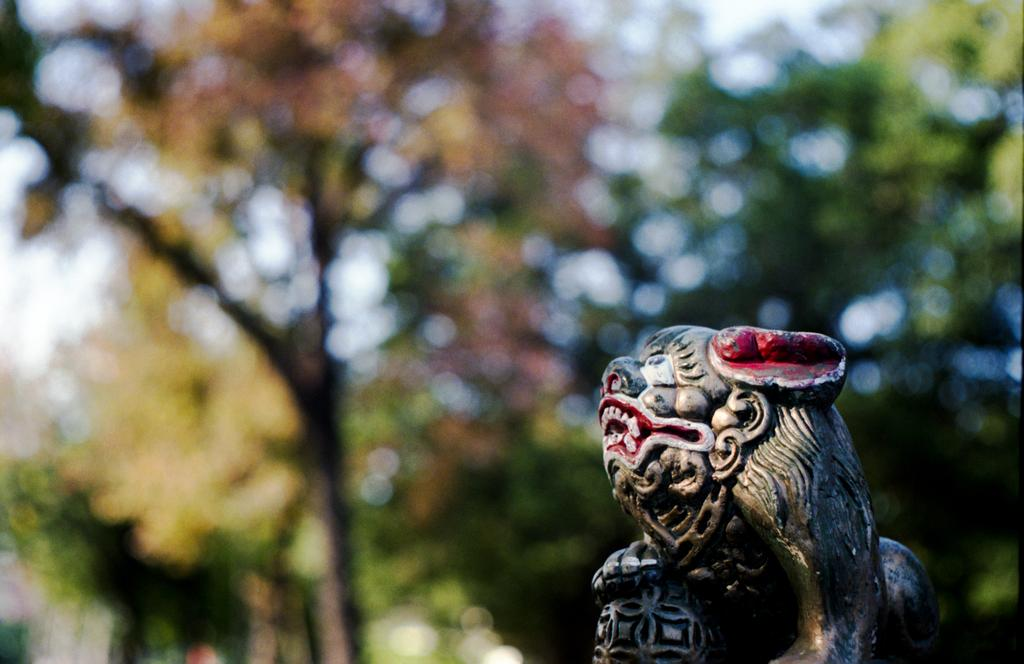What type of vegetation can be seen in the image? There are trees in the image. What part of the natural environment is visible in the image? The sky is visible in the image. What type of wilderness can be seen in the image? There is no specific wilderness mentioned or depicted in the image; it simply shows trees and the sky. Can you describe the slope of the terrain in the image? There is no indication of a slope or any specific terrain features in the image; it only shows trees and the sky. 